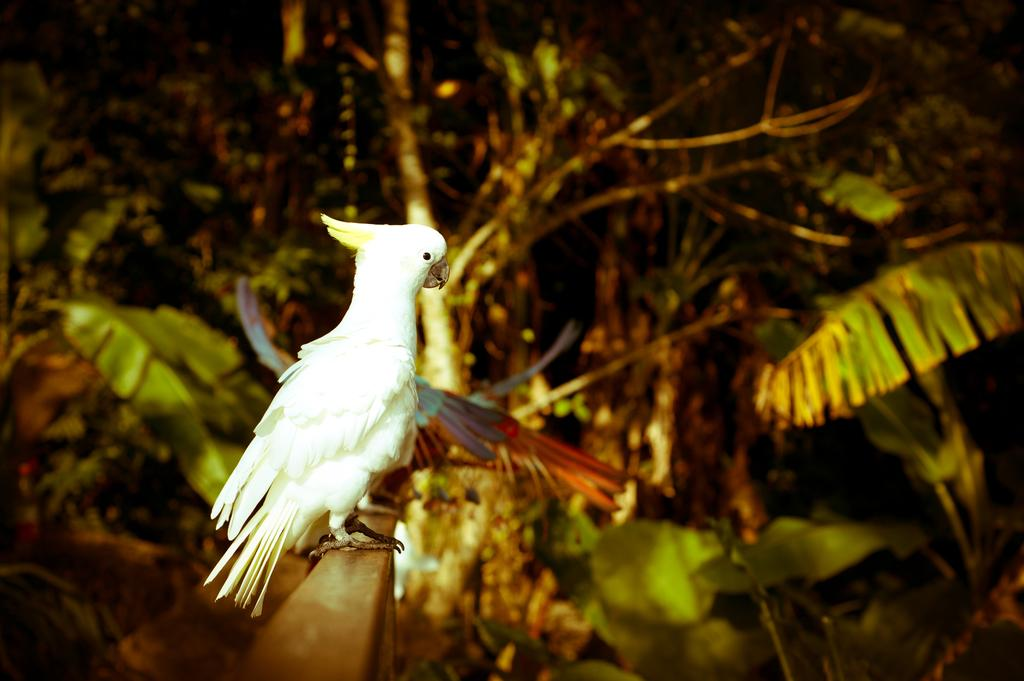What type of animal is in the image? There is a parrot in the image. What color is the parrot? The parrot is white in color. What type of vegetation is present in the image? There are green color trees in the image. What type of truck can be seen parked near the trees in the image? There is no truck present in the image; it only features a white parrot and green trees. Can you tell me the value of the stamp on the parrot's wing in the image? There is no stamp present on the parrot's wing in the image. 